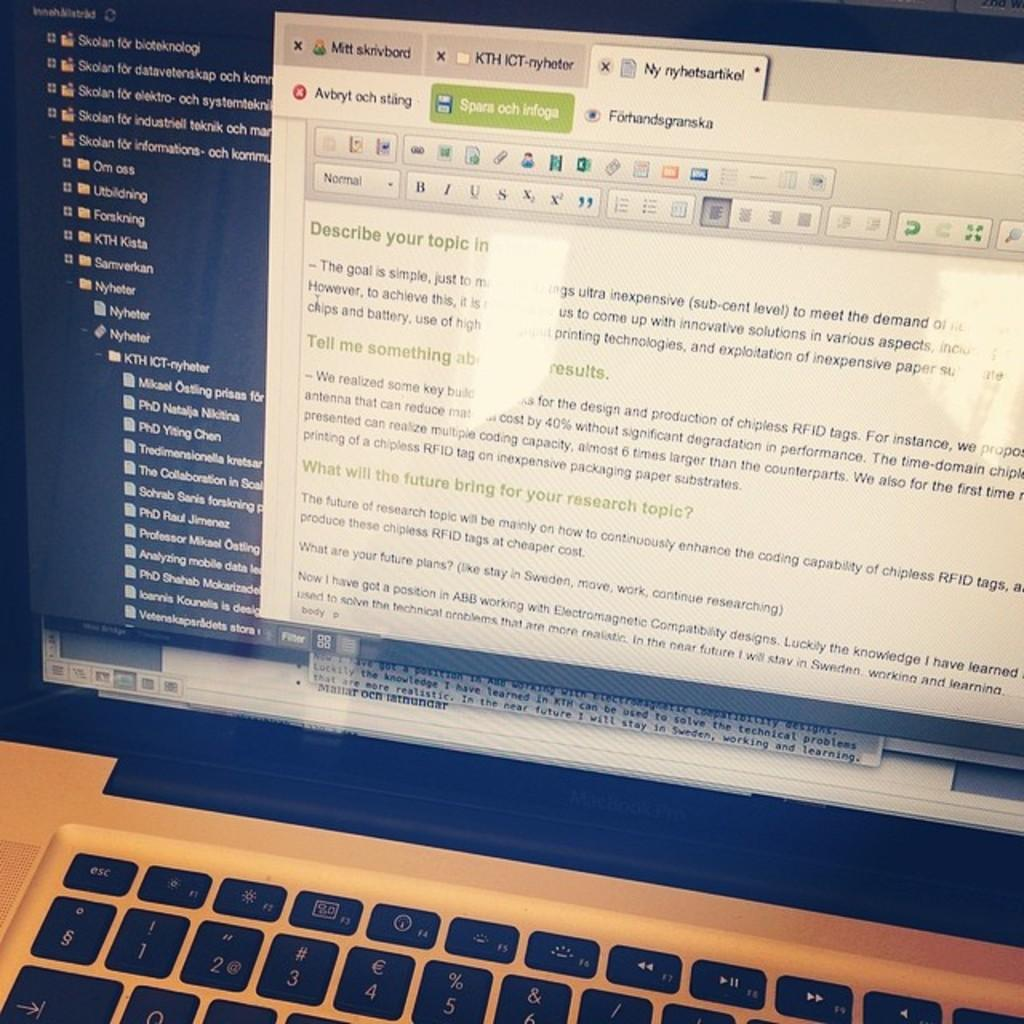<image>
Relay a brief, clear account of the picture shown. A laptop is shown on a my nyhetsartikel screen. 